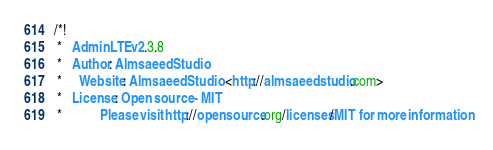<code> <loc_0><loc_0><loc_500><loc_500><_CSS_>
/*!
 *   AdminLTE v2.3.8
 *   Author: Almsaeed Studio
 *	 Website: Almsaeed Studio <http://almsaeedstudio.com>
 *   License: Open source - MIT
 *           Please visit http://opensource.org/licenses/MIT for more information</code> 